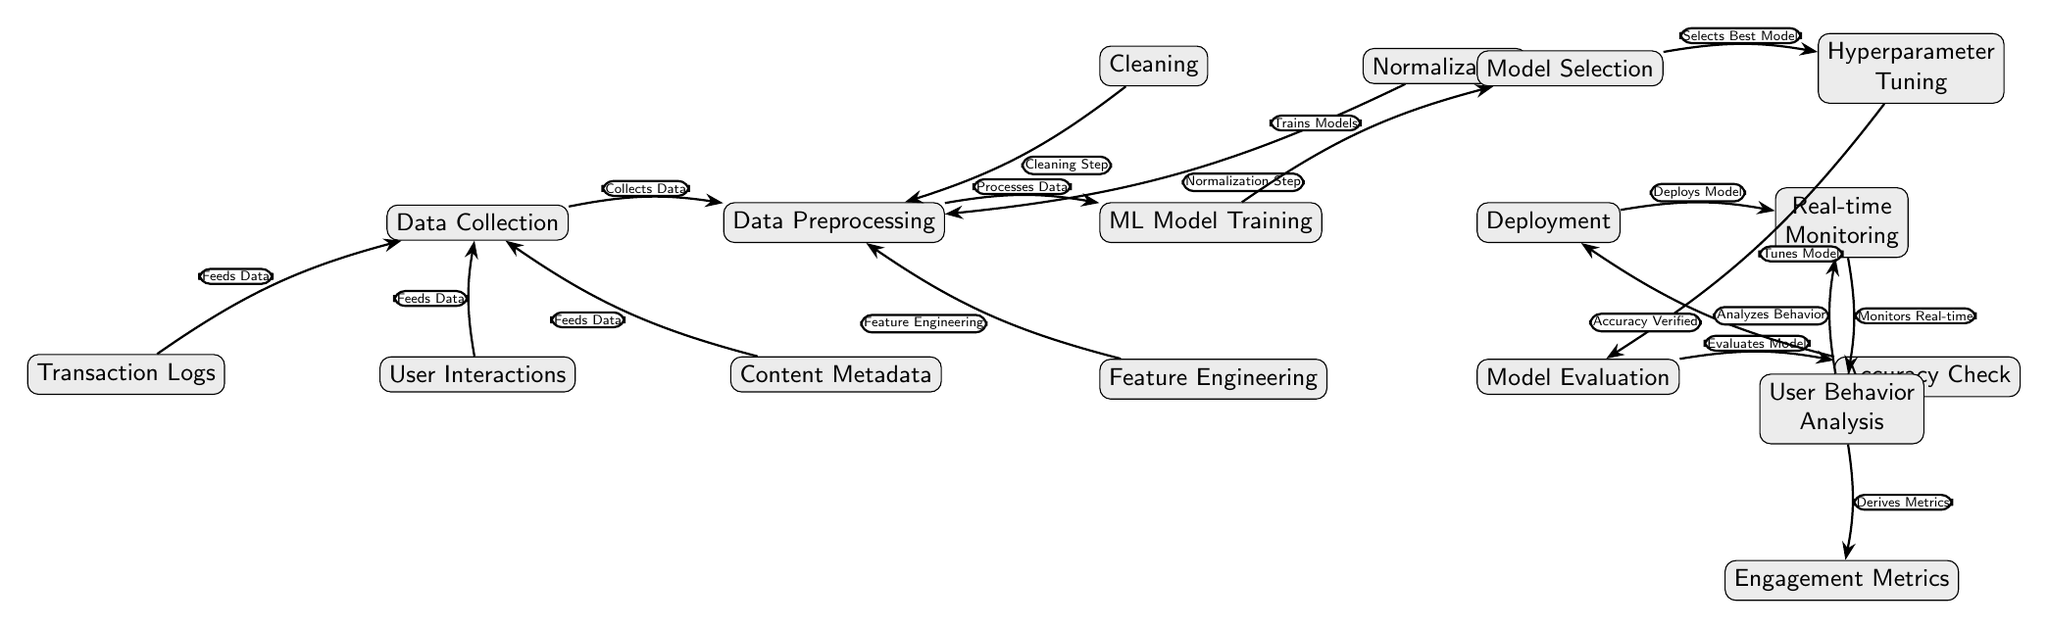What node represents the initial step in analyzing user interactions? The initial step in the diagram is labeled "Data Collection," which is the first node that processes data related to user interactions.
Answer: Data Collection How many nodes are involved in the ML Model Training process? In the diagram, there are four nodes directly related to ML Model Training: "ML Model Training," "Model Selection," "Hyperparameter Tuning," and "Model Evaluation."
Answer: Four What is the relationship between User Interactions and Data Collection? The diagram shows that User Interactions "Feeds Data" into Data Collection, indicating a direct input relationship where user actions contribute data for analysis.
Answer: Feeds Data What is the final output of the entire process? The final output of the diagram is "Engagement Metrics," which represents the analytic results derived from user behavior analysis after the model has been deployed and monitored.
Answer: Engagement Metrics What step comes after model evaluation? After "Model Evaluation," the next step is "Accuracy Check," which ensures that the model's predictions meet acceptable accuracy standards before deployment.
Answer: Accuracy Check Which node is responsible for monitoring the model in real time? The node labeled "Real-time Monitoring" is specifically responsible for the continuous observation of the model's performance once it is deployed.
Answer: Real-time Monitoring What process takes place immediately after feature engineering? "Feature Engineering" directly leads into "Data Preprocessing," as it is part of the data preparation stages crucial for machine learning.
Answer: Data Preprocessing How does "Transaction Logs" relate to the overall diagram? "Transaction Logs" is one of the three inputs to "Data Collection," contributing data necessary for analyzing user interactions in the digital library platform.
Answer: Feeds Data What nodes are associated with the cleaning process? The "Cleaning" node is directly linked to "Data Preprocessing," indicating that it is a crucial component in preparing data for machine learning modeling.
Answer: Data Preprocessing 